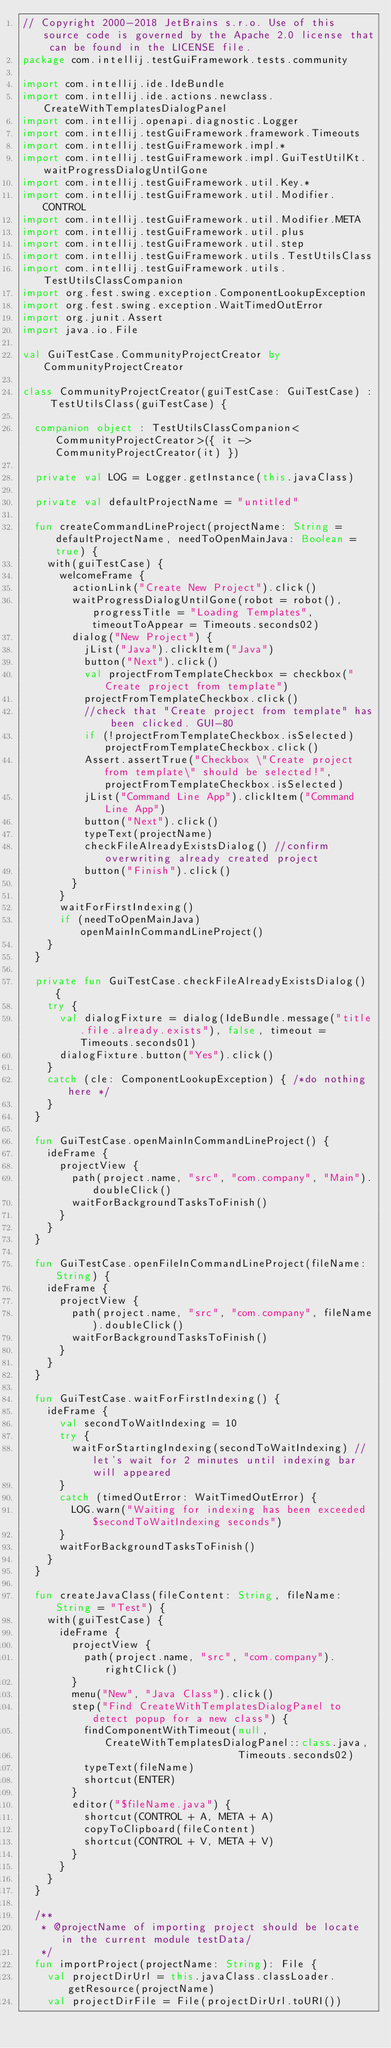Convert code to text. <code><loc_0><loc_0><loc_500><loc_500><_Kotlin_>// Copyright 2000-2018 JetBrains s.r.o. Use of this source code is governed by the Apache 2.0 license that can be found in the LICENSE file.
package com.intellij.testGuiFramework.tests.community

import com.intellij.ide.IdeBundle
import com.intellij.ide.actions.newclass.CreateWithTemplatesDialogPanel
import com.intellij.openapi.diagnostic.Logger
import com.intellij.testGuiFramework.framework.Timeouts
import com.intellij.testGuiFramework.impl.*
import com.intellij.testGuiFramework.impl.GuiTestUtilKt.waitProgressDialogUntilGone
import com.intellij.testGuiFramework.util.Key.*
import com.intellij.testGuiFramework.util.Modifier.CONTROL
import com.intellij.testGuiFramework.util.Modifier.META
import com.intellij.testGuiFramework.util.plus
import com.intellij.testGuiFramework.util.step
import com.intellij.testGuiFramework.utils.TestUtilsClass
import com.intellij.testGuiFramework.utils.TestUtilsClassCompanion
import org.fest.swing.exception.ComponentLookupException
import org.fest.swing.exception.WaitTimedOutError
import org.junit.Assert
import java.io.File

val GuiTestCase.CommunityProjectCreator by CommunityProjectCreator

class CommunityProjectCreator(guiTestCase: GuiTestCase) : TestUtilsClass(guiTestCase) {

  companion object : TestUtilsClassCompanion<CommunityProjectCreator>({ it -> CommunityProjectCreator(it) })

  private val LOG = Logger.getInstance(this.javaClass)

  private val defaultProjectName = "untitled"

  fun createCommandLineProject(projectName: String = defaultProjectName, needToOpenMainJava: Boolean = true) {
    with(guiTestCase) {
      welcomeFrame {
        actionLink("Create New Project").click()
        waitProgressDialogUntilGone(robot = robot(), progressTitle = "Loading Templates", timeoutToAppear = Timeouts.seconds02)
        dialog("New Project") {
          jList("Java").clickItem("Java")
          button("Next").click()
          val projectFromTemplateCheckbox = checkbox("Create project from template")
          projectFromTemplateCheckbox.click()
          //check that "Create project from template" has been clicked. GUI-80
          if (!projectFromTemplateCheckbox.isSelected) projectFromTemplateCheckbox.click()
          Assert.assertTrue("Checkbox \"Create project from template\" should be selected!", projectFromTemplateCheckbox.isSelected)
          jList("Command Line App").clickItem("Command Line App")
          button("Next").click()
          typeText(projectName)
          checkFileAlreadyExistsDialog() //confirm overwriting already created project
          button("Finish").click()
        }
      }
      waitForFirstIndexing()
      if (needToOpenMainJava) openMainInCommandLineProject()
    }
  }

  private fun GuiTestCase.checkFileAlreadyExistsDialog() {
    try {
      val dialogFixture = dialog(IdeBundle.message("title.file.already.exists"), false, timeout = Timeouts.seconds01)
      dialogFixture.button("Yes").click()
    }
    catch (cle: ComponentLookupException) { /*do nothing here */
    }
  }

  fun GuiTestCase.openMainInCommandLineProject() {
    ideFrame {
      projectView {
        path(project.name, "src", "com.company", "Main").doubleClick()
        waitForBackgroundTasksToFinish()
      }
    }
  }

  fun GuiTestCase.openFileInCommandLineProject(fileName: String) {
    ideFrame {
      projectView {
        path(project.name, "src", "com.company", fileName).doubleClick()
        waitForBackgroundTasksToFinish()
      }
    }
  }

  fun GuiTestCase.waitForFirstIndexing() {
    ideFrame {
      val secondToWaitIndexing = 10
      try {
        waitForStartingIndexing(secondToWaitIndexing) //let's wait for 2 minutes until indexing bar will appeared
      }
      catch (timedOutError: WaitTimedOutError) {
        LOG.warn("Waiting for indexing has been exceeded $secondToWaitIndexing seconds")
      }
      waitForBackgroundTasksToFinish()
    }
  }

  fun createJavaClass(fileContent: String, fileName: String = "Test") {
    with(guiTestCase) {
      ideFrame {
        projectView {
          path(project.name, "src", "com.company").rightClick()
        }
        menu("New", "Java Class").click()
        step("Find CreateWithTemplatesDialogPanel to detect popup for a new class") {
          findComponentWithTimeout(null, CreateWithTemplatesDialogPanel::class.java,
                                   Timeouts.seconds02)
          typeText(fileName)
          shortcut(ENTER)
        }
        editor("$fileName.java") {
          shortcut(CONTROL + A, META + A)
          copyToClipboard(fileContent)
          shortcut(CONTROL + V, META + V)
        }
      }
    }
  }

  /**
   * @projectName of importing project should be locate in the current module testData/
   */
  fun importProject(projectName: String): File {
    val projectDirUrl = this.javaClass.classLoader.getResource(projectName)
    val projectDirFile = File(projectDirUrl.toURI())</code> 